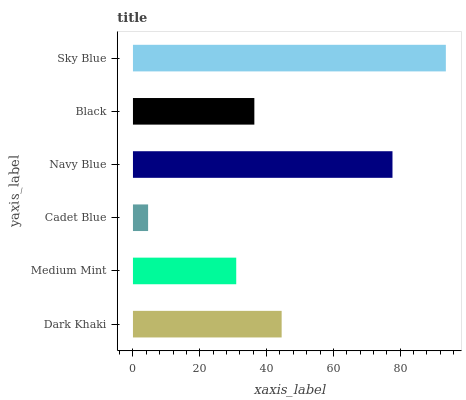Is Cadet Blue the minimum?
Answer yes or no. Yes. Is Sky Blue the maximum?
Answer yes or no. Yes. Is Medium Mint the minimum?
Answer yes or no. No. Is Medium Mint the maximum?
Answer yes or no. No. Is Dark Khaki greater than Medium Mint?
Answer yes or no. Yes. Is Medium Mint less than Dark Khaki?
Answer yes or no. Yes. Is Medium Mint greater than Dark Khaki?
Answer yes or no. No. Is Dark Khaki less than Medium Mint?
Answer yes or no. No. Is Dark Khaki the high median?
Answer yes or no. Yes. Is Black the low median?
Answer yes or no. Yes. Is Navy Blue the high median?
Answer yes or no. No. Is Medium Mint the low median?
Answer yes or no. No. 